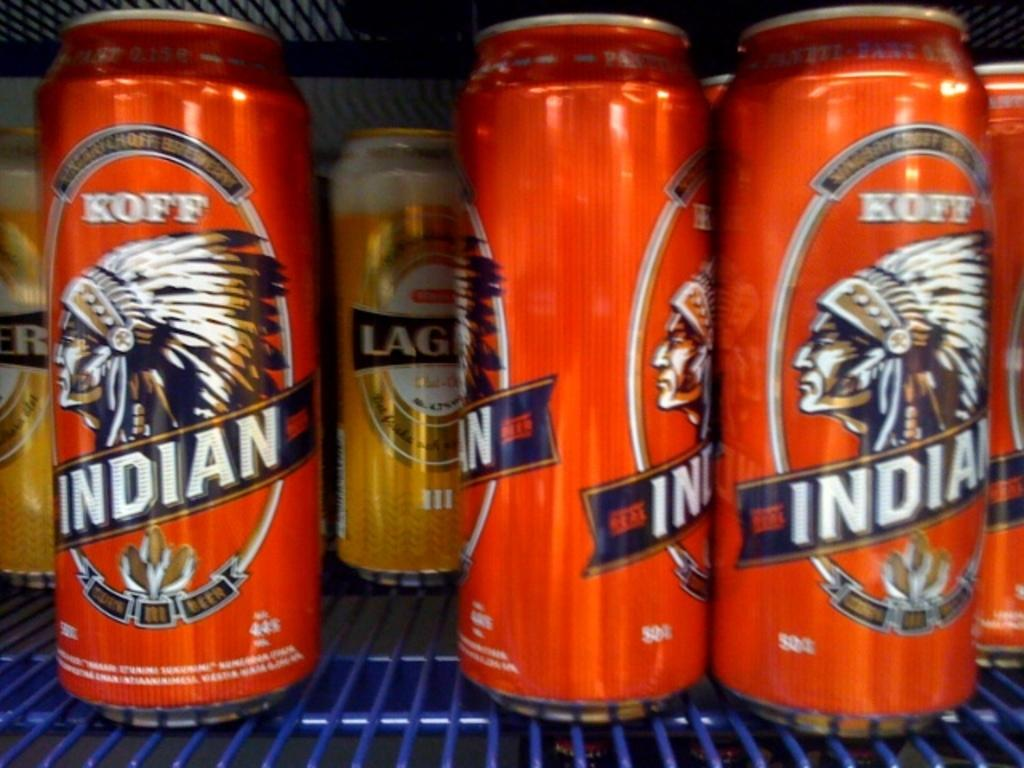<image>
Write a terse but informative summary of the picture. Koof Indian beer cans that are colored orange located on a shelf. 